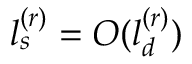Convert formula to latex. <formula><loc_0><loc_0><loc_500><loc_500>l _ { s } ^ { ( r ) } = O ( l _ { d } ^ { ( r ) } )</formula> 